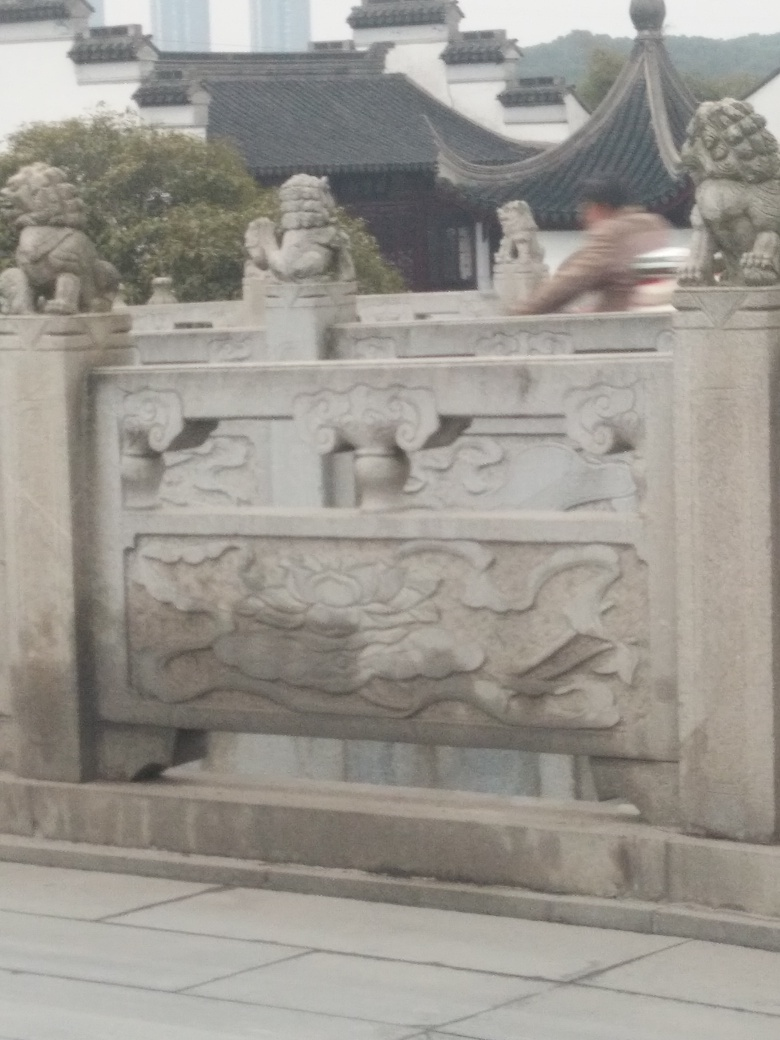Has the main subject lost most of the texture details? The main subject, which appears to be a stone railing with intricate carvings, displays blurred texture details due to the photograph's motion blur. This effect reduces the visual clarity of the textures, yet some details of the carving designs remain perceptible despite the lack of sharp focus. 